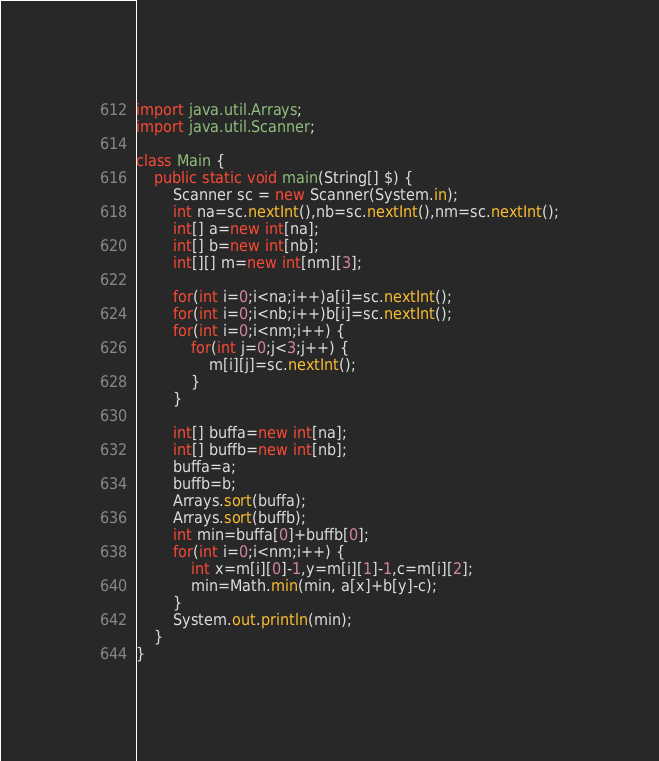Convert code to text. <code><loc_0><loc_0><loc_500><loc_500><_Java_>import java.util.Arrays;
import java.util.Scanner;

class Main {
	public static void main(String[] $) {
		Scanner sc = new Scanner(System.in);
		int na=sc.nextInt(),nb=sc.nextInt(),nm=sc.nextInt();
		int[] a=new int[na];
		int[] b=new int[nb];
		int[][] m=new int[nm][3];
		
		for(int i=0;i<na;i++)a[i]=sc.nextInt();
		for(int i=0;i<nb;i++)b[i]=sc.nextInt();
		for(int i=0;i<nm;i++) {
			for(int j=0;j<3;j++) {
				m[i][j]=sc.nextInt();
			}
		}
		
		int[] buffa=new int[na];
		int[] buffb=new int[nb];
		buffa=a;
		buffb=b;
		Arrays.sort(buffa);
		Arrays.sort(buffb);
		int min=buffa[0]+buffb[0];
		for(int i=0;i<nm;i++) {
			int x=m[i][0]-1,y=m[i][1]-1,c=m[i][2];
			min=Math.min(min, a[x]+b[y]-c);
		}
		System.out.println(min);
	}
}
</code> 